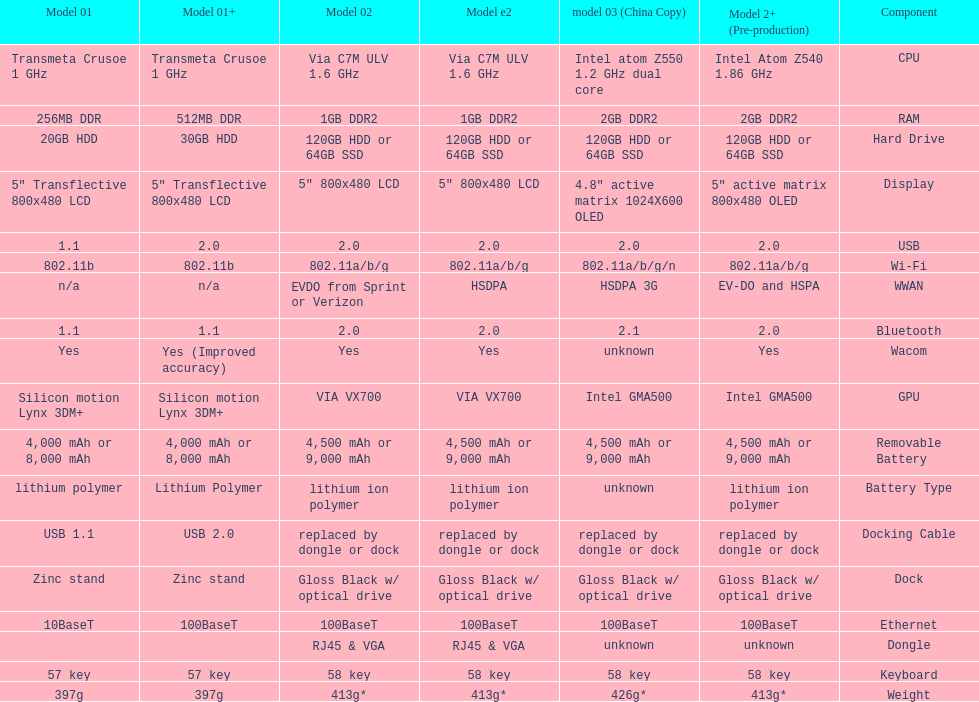How many models have 1.6ghz? 2. 